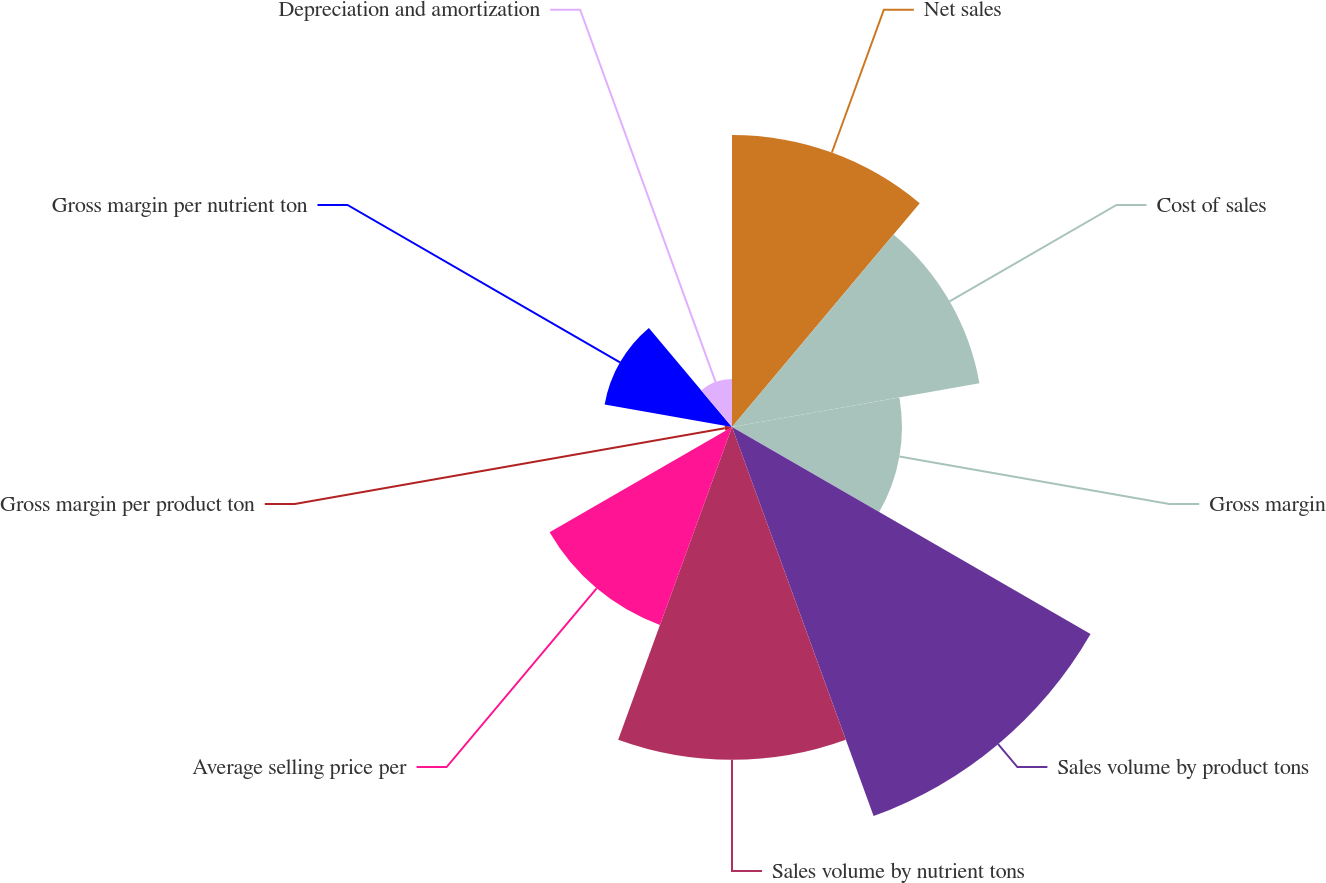Convert chart. <chart><loc_0><loc_0><loc_500><loc_500><pie_chart><fcel>Net sales<fcel>Cost of sales<fcel>Gross margin<fcel>Sales volume by product tons<fcel>Sales volume by nutrient tons<fcel>Average selling price per<fcel>Gross margin per product ton<fcel>Gross margin per nutrient ton<fcel>Depreciation and amortization<nl><fcel>15.74%<fcel>13.54%<fcel>9.16%<fcel>22.31%<fcel>17.93%<fcel>11.35%<fcel>0.4%<fcel>6.97%<fcel>2.59%<nl></chart> 